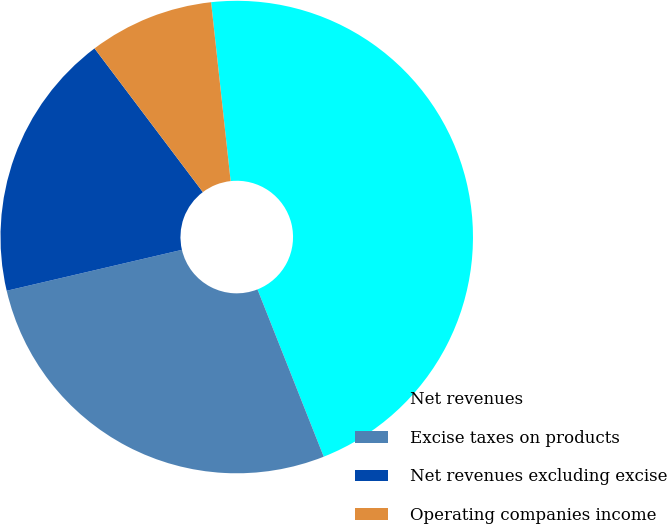Convert chart. <chart><loc_0><loc_0><loc_500><loc_500><pie_chart><fcel>Net revenues<fcel>Excise taxes on products<fcel>Net revenues excluding excise<fcel>Operating companies income<nl><fcel>45.73%<fcel>27.35%<fcel>18.37%<fcel>8.55%<nl></chart> 